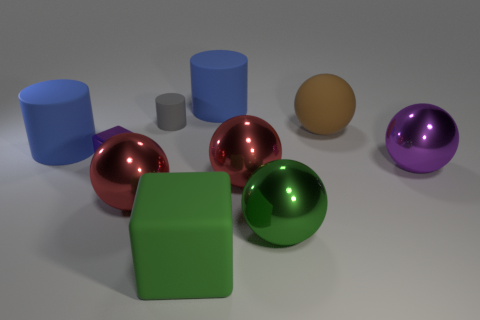What can you tell me about the lighting and shadows in the scene? The lighting in the scene seems to be coming from the upper left, casting soft shadows on the right side of each object. The shadows are consistent with the placement of the light source, indicating a single, diffuse light illuminating the scene. How does the lighting affect the appearance of the objects? The light source creates a sense of depth and three-dimensionality, enhancing the reflective properties of the metallic surfaces and creating a soft gradient on the matte surfaces, such as the green cube and the grey cylinder. 